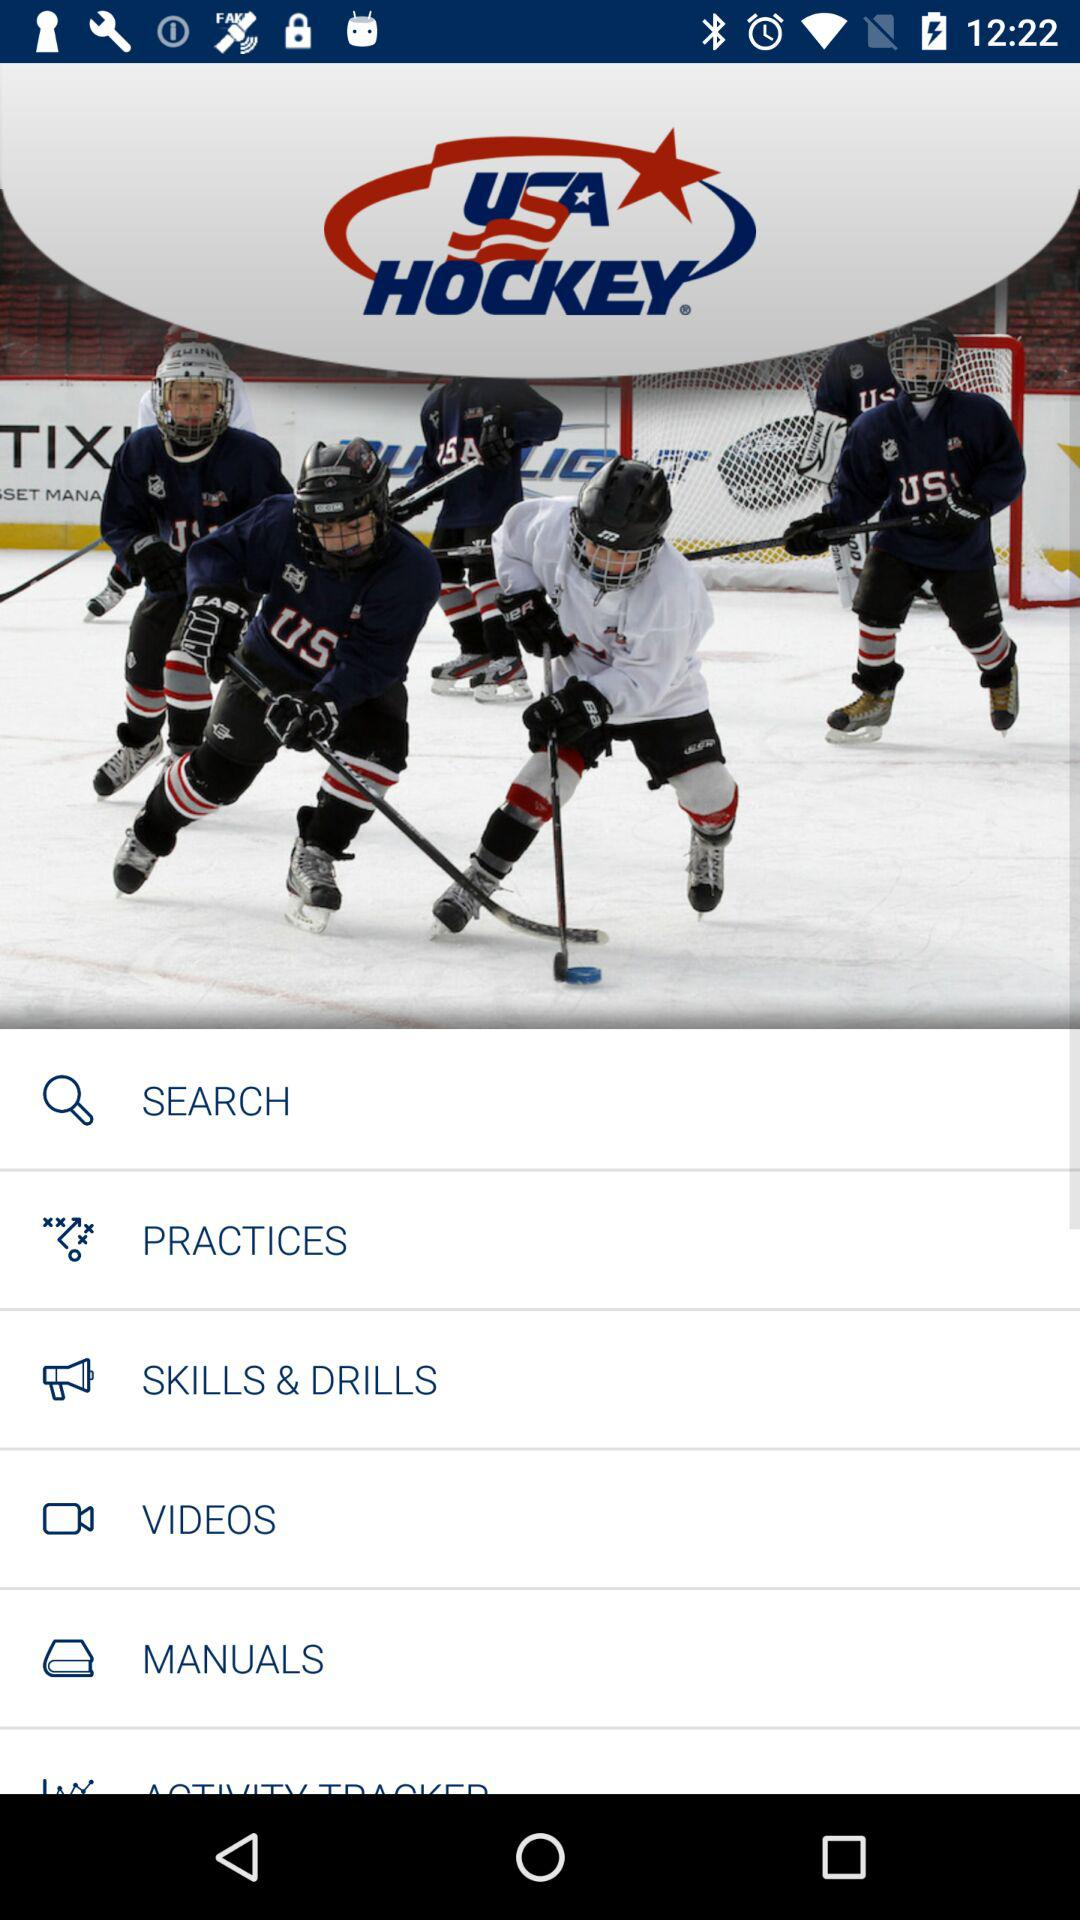What is the name of the application? The name of the application is "USA HOCKEY". 